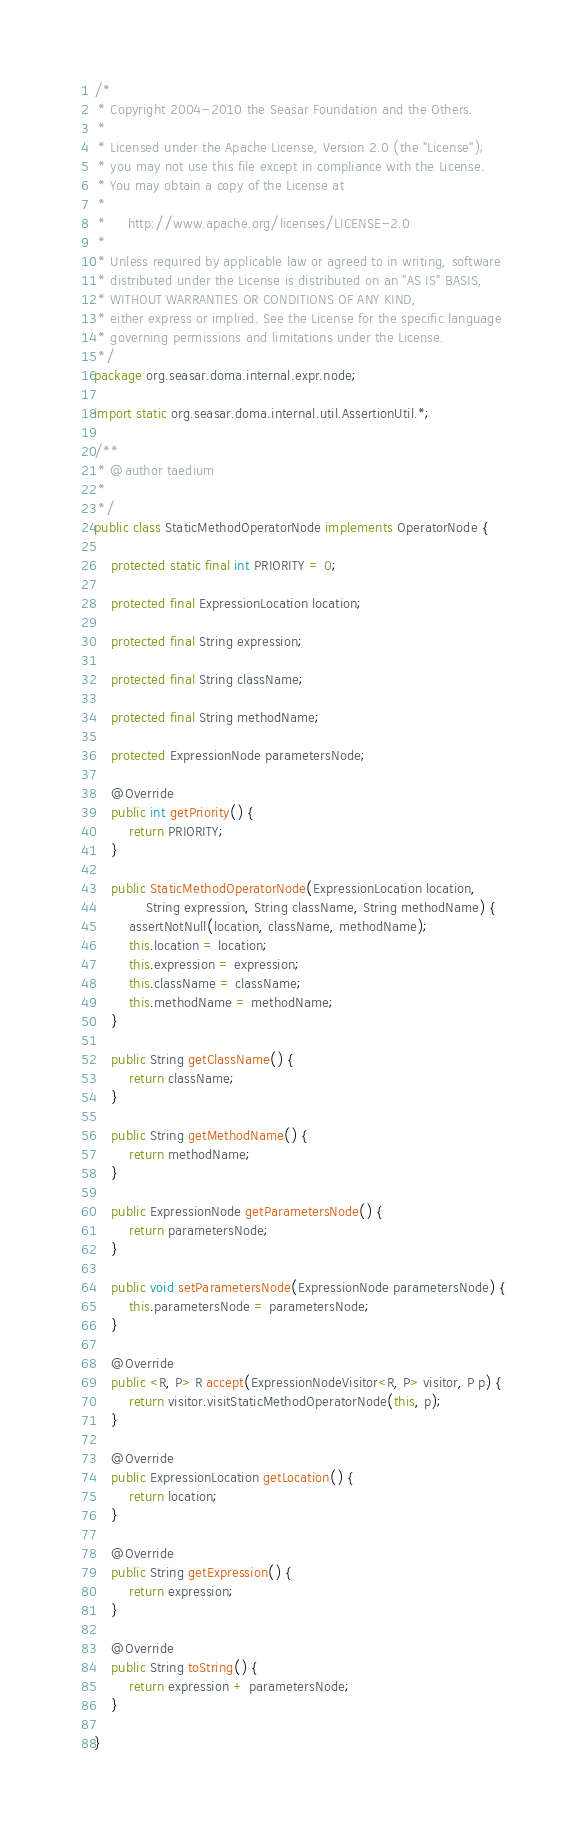<code> <loc_0><loc_0><loc_500><loc_500><_Java_>/*
 * Copyright 2004-2010 the Seasar Foundation and the Others.
 *
 * Licensed under the Apache License, Version 2.0 (the "License");
 * you may not use this file except in compliance with the License.
 * You may obtain a copy of the License at
 *
 *     http://www.apache.org/licenses/LICENSE-2.0
 *
 * Unless required by applicable law or agreed to in writing, software
 * distributed under the License is distributed on an "AS IS" BASIS,
 * WITHOUT WARRANTIES OR CONDITIONS OF ANY KIND,
 * either express or implied. See the License for the specific language
 * governing permissions and limitations under the License.
 */
package org.seasar.doma.internal.expr.node;

import static org.seasar.doma.internal.util.AssertionUtil.*;

/**
 * @author taedium
 * 
 */
public class StaticMethodOperatorNode implements OperatorNode {

    protected static final int PRIORITY = 0;

    protected final ExpressionLocation location;

    protected final String expression;

    protected final String className;

    protected final String methodName;

    protected ExpressionNode parametersNode;

    @Override
    public int getPriority() {
        return PRIORITY;
    }

    public StaticMethodOperatorNode(ExpressionLocation location,
            String expression, String className, String methodName) {
        assertNotNull(location, className, methodName);
        this.location = location;
        this.expression = expression;
        this.className = className;
        this.methodName = methodName;
    }

    public String getClassName() {
        return className;
    }

    public String getMethodName() {
        return methodName;
    }

    public ExpressionNode getParametersNode() {
        return parametersNode;
    }

    public void setParametersNode(ExpressionNode parametersNode) {
        this.parametersNode = parametersNode;
    }

    @Override
    public <R, P> R accept(ExpressionNodeVisitor<R, P> visitor, P p) {
        return visitor.visitStaticMethodOperatorNode(this, p);
    }

    @Override
    public ExpressionLocation getLocation() {
        return location;
    }

    @Override
    public String getExpression() {
        return expression;
    }

    @Override
    public String toString() {
        return expression + parametersNode;
    }

}
</code> 